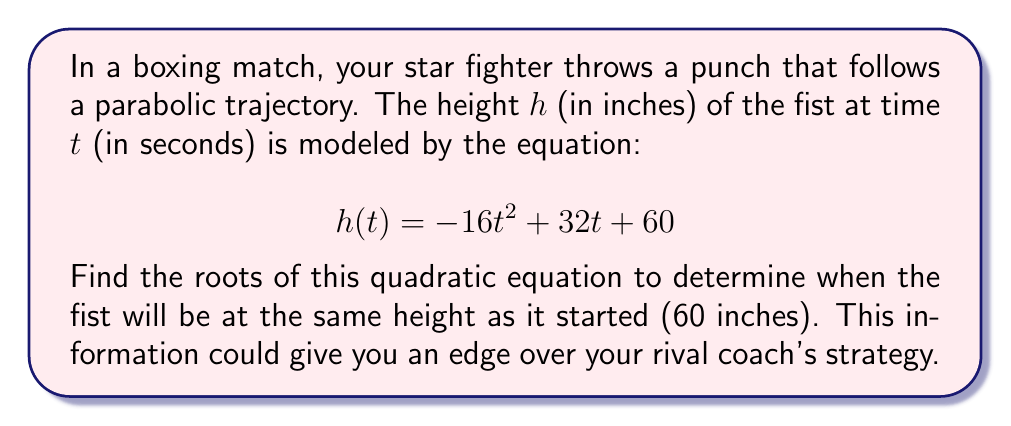Show me your answer to this math problem. To find the roots of the quadratic equation, we need to set $h(t) = 60$ and solve for $t$:

1) Set up the equation:
   $$ -16t^2 + 32t + 60 = 60 $$

2) Simplify by subtracting 60 from both sides:
   $$ -16t^2 + 32t = 0 $$

3) Factor out the greatest common factor:
   $$ -16t(t - 2) = 0 $$

4) Use the zero product property. Either $-16t = 0$ or $t - 2 = 0$:
   $$ t = 0 \text{ or } t = 2 $$

5) Interpret the results:
   - At $t = 0$, the fist is at its starting height (60 inches).
   - At $t = 2$, the fist returns to its starting height (60 inches).

The time between these roots (2 seconds) represents the total time of the punch's trajectory.
Answer: $t = 0$ and $t = 2$ 